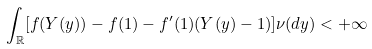<formula> <loc_0><loc_0><loc_500><loc_500>\int _ { \mathbb { R } } [ f ( Y ( y ) ) - f ( 1 ) - f ^ { \prime } ( 1 ) ( Y ( y ) - 1 ) ] \nu ( d y ) < + \infty</formula> 